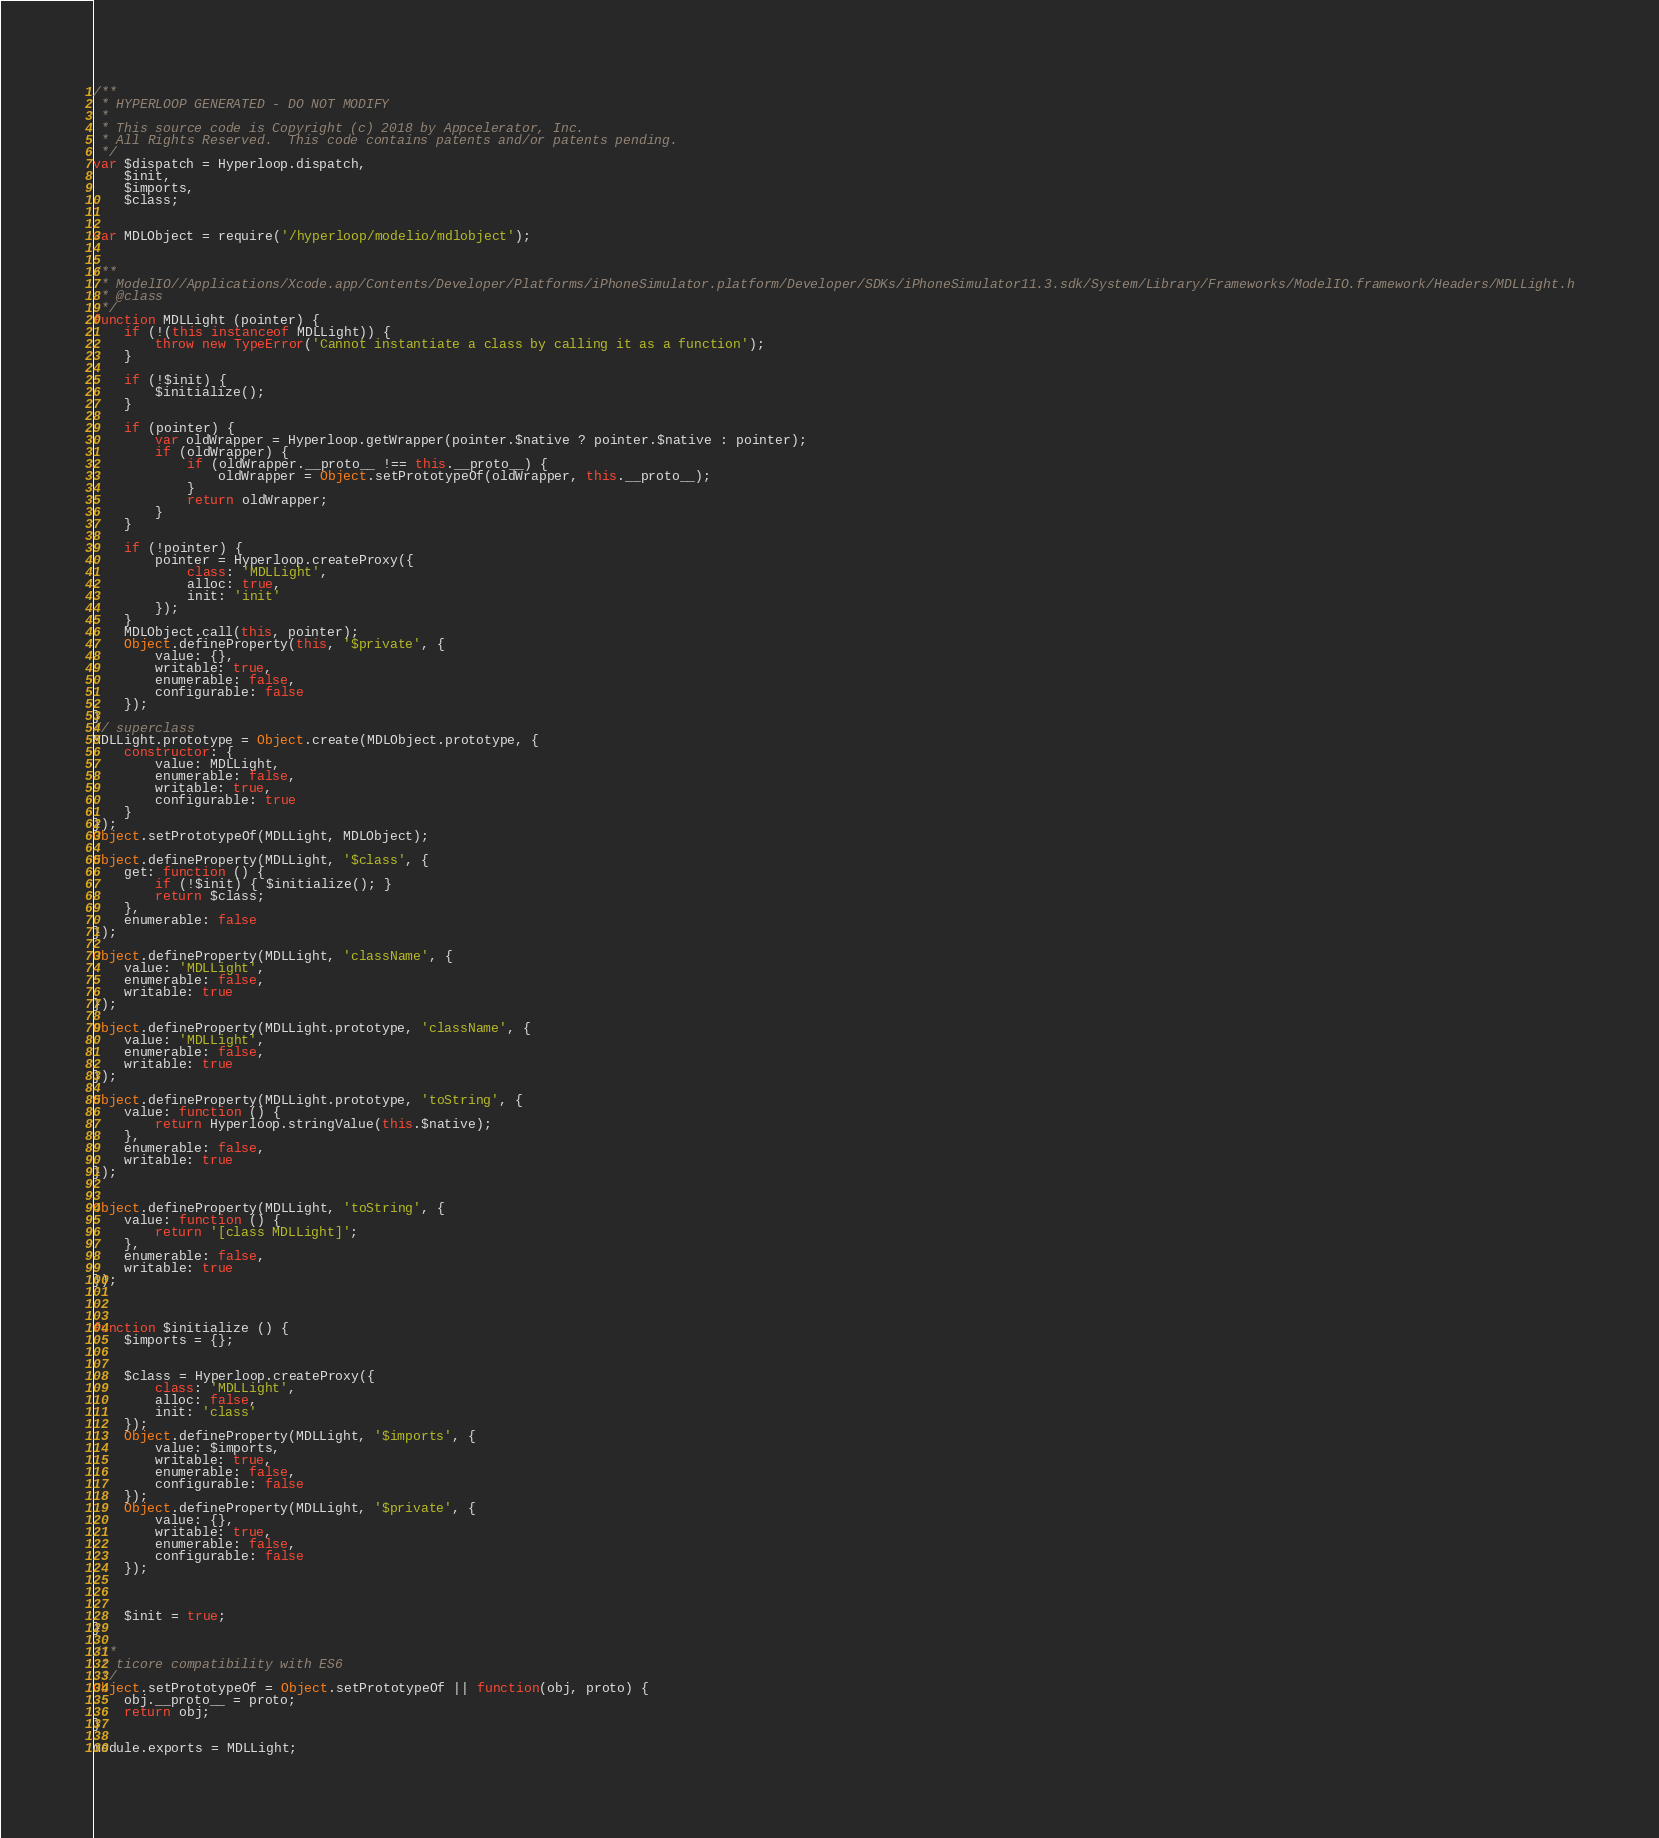Convert code to text. <code><loc_0><loc_0><loc_500><loc_500><_JavaScript_>/**
 * HYPERLOOP GENERATED - DO NOT MODIFY
 *
 * This source code is Copyright (c) 2018 by Appcelerator, Inc.
 * All Rights Reserved.  This code contains patents and/or patents pending.
 */
var $dispatch = Hyperloop.dispatch,
	$init,
	$imports,
	$class;


var MDLObject = require('/hyperloop/modelio/mdlobject');


/**
 * ModelIO//Applications/Xcode.app/Contents/Developer/Platforms/iPhoneSimulator.platform/Developer/SDKs/iPhoneSimulator11.3.sdk/System/Library/Frameworks/ModelIO.framework/Headers/MDLLight.h
 * @class
 */
function MDLLight (pointer) {
	if (!(this instanceof MDLLight)) {
		throw new TypeError('Cannot instantiate a class by calling it as a function');
	}

	if (!$init) {
		$initialize();
	}

	if (pointer) {
		var oldWrapper = Hyperloop.getWrapper(pointer.$native ? pointer.$native : pointer);
		if (oldWrapper) {
			if (oldWrapper.__proto__ !== this.__proto__) {
				oldWrapper = Object.setPrototypeOf(oldWrapper, this.__proto__);
			}
			return oldWrapper;
		}
	}

	if (!pointer) {
		pointer = Hyperloop.createProxy({
			class: 'MDLLight',
			alloc: true,
			init: 'init'
		});
	}
	MDLObject.call(this, pointer);
	Object.defineProperty(this, '$private', {
		value: {},
		writable: true,
		enumerable: false,
		configurable: false
	});
}
// superclass
MDLLight.prototype = Object.create(MDLObject.prototype, {
	constructor: {
		value: MDLLight,
		enumerable: false,
		writable: true,
		configurable: true
	}
});
Object.setPrototypeOf(MDLLight, MDLObject);

Object.defineProperty(MDLLight, '$class', {
	get: function () {
		if (!$init) { $initialize(); }
		return $class;
	},
	enumerable: false
});

Object.defineProperty(MDLLight, 'className', {
	value: 'MDLLight',
	enumerable: false,
	writable: true
});

Object.defineProperty(MDLLight.prototype, 'className', {
	value: 'MDLLight',
	enumerable: false,
	writable: true
});

Object.defineProperty(MDLLight.prototype, 'toString', {
	value: function () {
		return Hyperloop.stringValue(this.$native);
	},
	enumerable: false,
	writable: true
});


Object.defineProperty(MDLLight, 'toString', {
	value: function () {
		return '[class MDLLight]';
	},
	enumerable: false,
	writable: true
});



function $initialize () {
	$imports = {};


	$class = Hyperloop.createProxy({
		class: 'MDLLight',
		alloc: false,
		init: 'class'
	});
	Object.defineProperty(MDLLight, '$imports', {
		value: $imports,
		writable: true,
		enumerable: false,
		configurable: false
	});
	Object.defineProperty(MDLLight, '$private', {
		value: {},
		writable: true,
		enumerable: false,
		configurable: false
	});



	$init = true;
}

/**
 * ticore compatibility with ES6
 */
Object.setPrototypeOf = Object.setPrototypeOf || function(obj, proto) {
	obj.__proto__ = proto;
	return obj;
}

module.exports = MDLLight;
</code> 